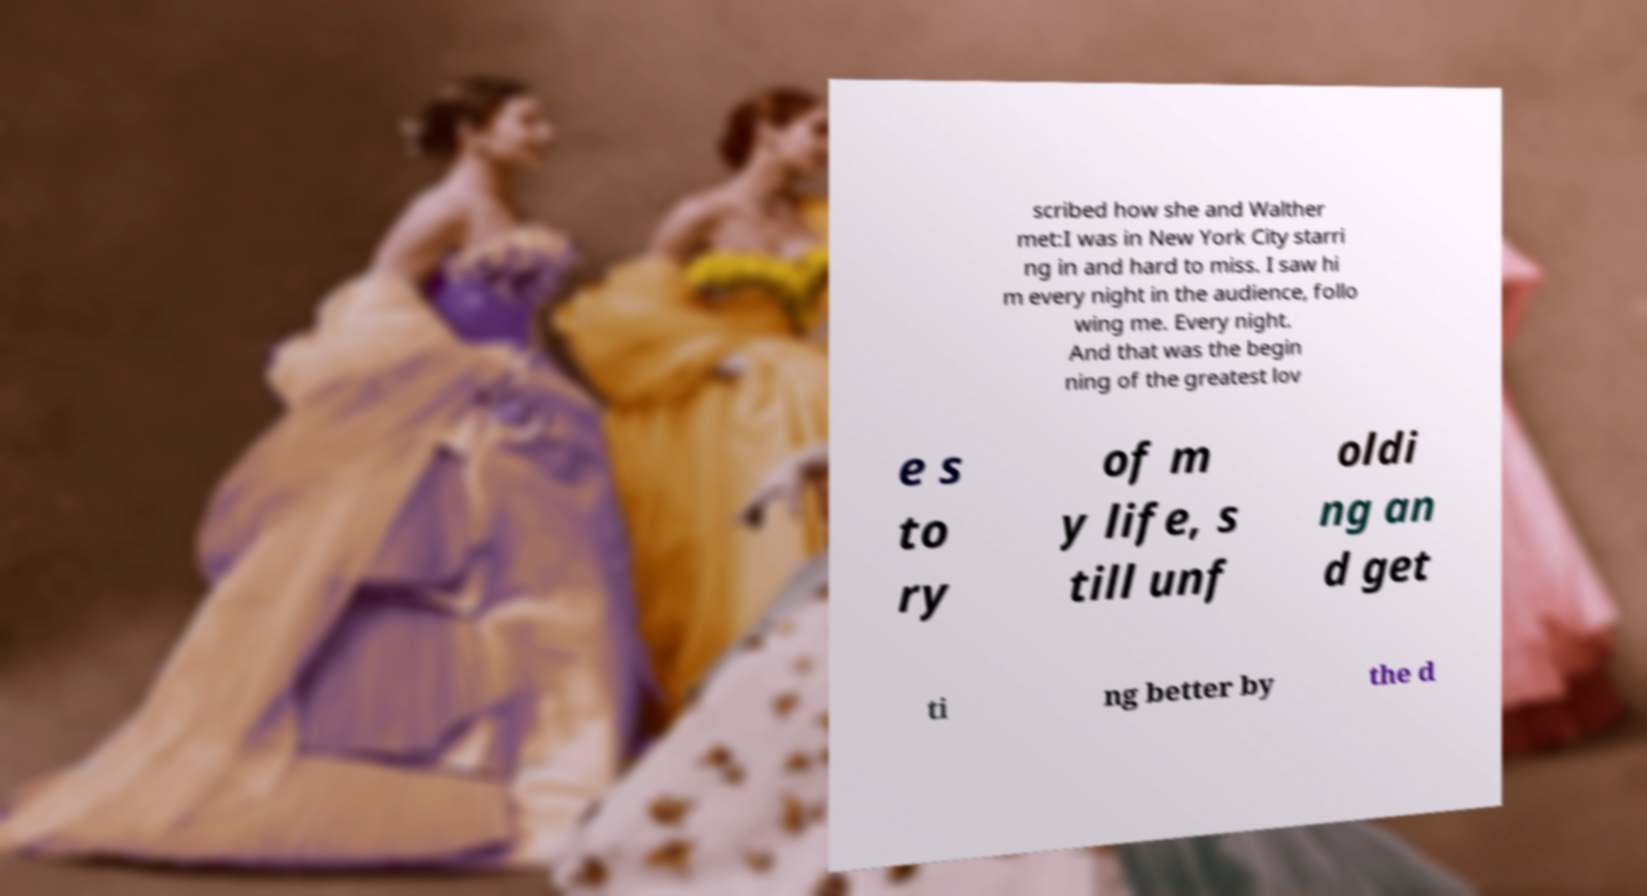What messages or text are displayed in this image? I need them in a readable, typed format. scribed how she and Walther met:I was in New York City starri ng in and hard to miss. I saw hi m every night in the audience, follo wing me. Every night. And that was the begin ning of the greatest lov e s to ry of m y life, s till unf oldi ng an d get ti ng better by the d 